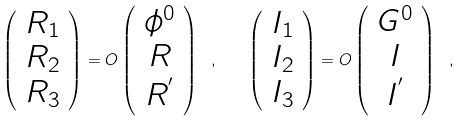<formula> <loc_0><loc_0><loc_500><loc_500>\left ( \begin{array} { c } R _ { 1 } \\ R _ { 2 } \\ R _ { 3 } \end{array} \right ) = O \left ( \begin{array} { c } \phi ^ { 0 } \\ R \\ R ^ { ^ { \prime } } \end{array} \right ) \ , \quad \left ( \begin{array} { c } I _ { 1 } \\ I _ { 2 } \\ I _ { 3 } \end{array} \right ) = O \left ( \begin{array} { c } G ^ { 0 } \\ I \\ I ^ { ^ { \prime } } \end{array} \right ) \ ,</formula> 